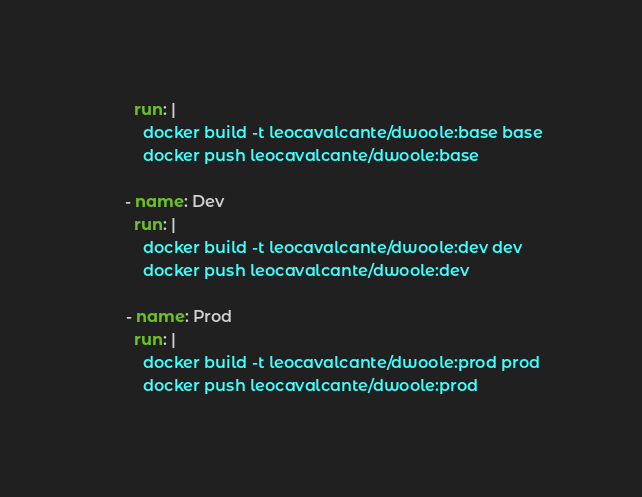Convert code to text. <code><loc_0><loc_0><loc_500><loc_500><_YAML_>        run: |
          docker build -t leocavalcante/dwoole:base base
          docker push leocavalcante/dwoole:base

      - name: Dev
        run: |
          docker build -t leocavalcante/dwoole:dev dev
          docker push leocavalcante/dwoole:dev

      - name: Prod
        run: |
          docker build -t leocavalcante/dwoole:prod prod
          docker push leocavalcante/dwoole:prod
</code> 